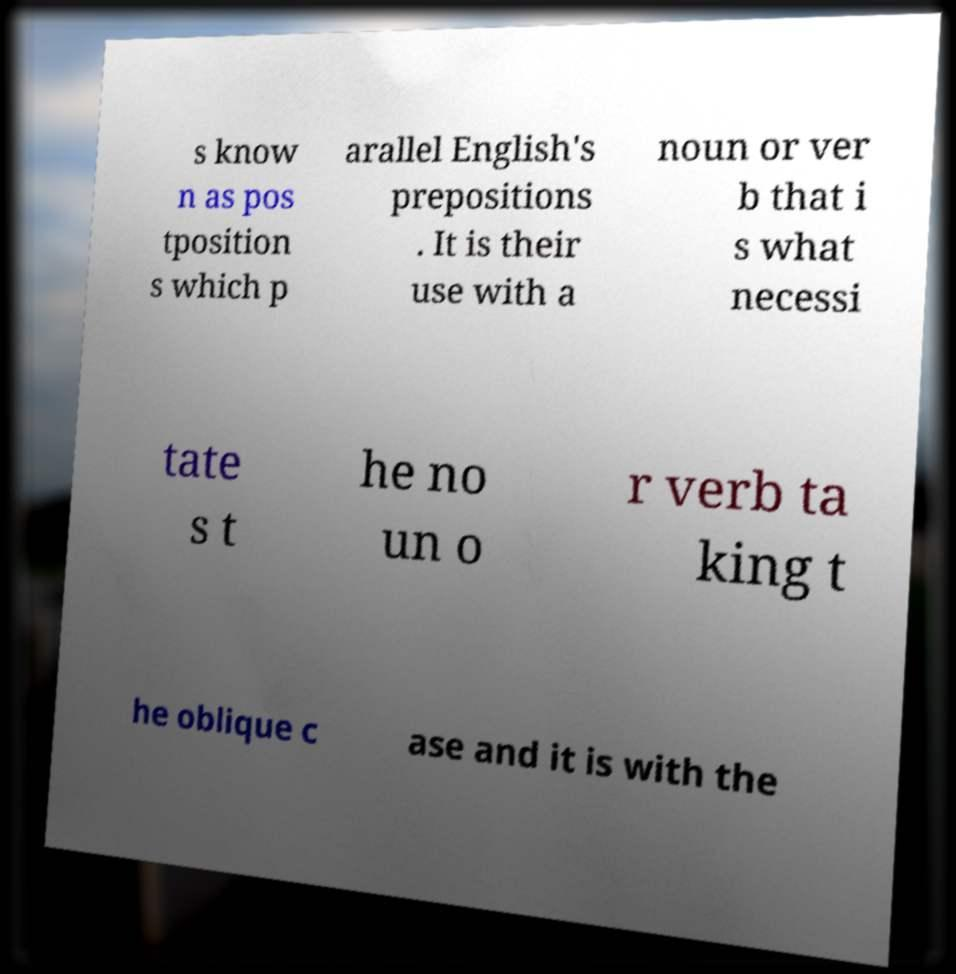Can you accurately transcribe the text from the provided image for me? s know n as pos tposition s which p arallel English's prepositions . It is their use with a noun or ver b that i s what necessi tate s t he no un o r verb ta king t he oblique c ase and it is with the 